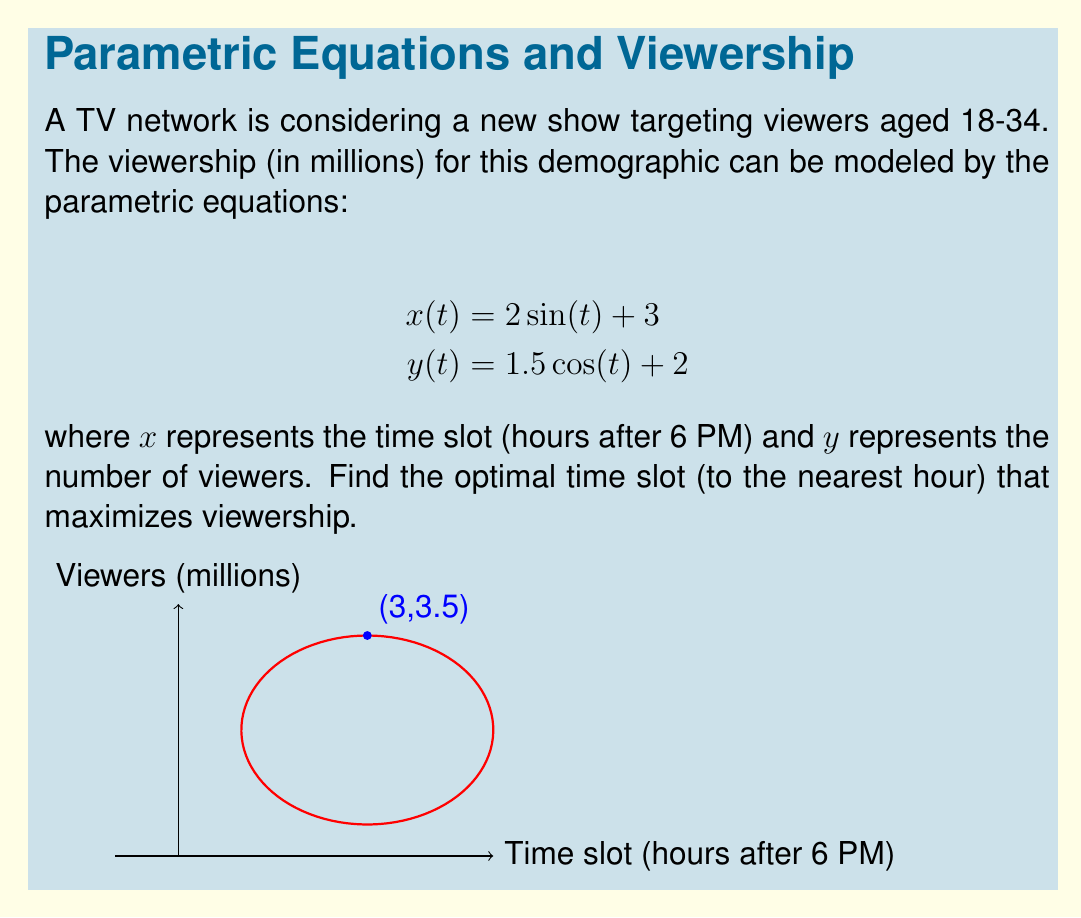Can you answer this question? To find the optimal time slot, we need to determine the maximum value of $y(t)$ and its corresponding $x(t)$ value. Let's approach this step-by-step:

1) The maximum value of $y(t)$ occurs when $\cos(t)$ is at its maximum, which is 1. This happens when $t = 0$ or $2\pi$.

2) At this point:
   $y_{max} = 1.5(1) + 2 = 3.5$ million viewers

3) To find the corresponding time slot, we need to calculate $x(t)$ when $t = 0$:
   $x(0) = 2\sin(0) + 3 = 3$

4) This means the optimal time slot is 3 hours after 6 PM, which is 9 PM.

5) To verify, let's check the other solution ($t = 2\pi$):
   $x(2\pi) = 2\sin(2\pi) + 3 = 3$

Both solutions give the same result, confirming that 9 PM (3 hours after 6 PM) is the optimal time slot.

6) Rounding to the nearest hour is not necessary in this case as the result is already a whole number.
Answer: 9 PM 